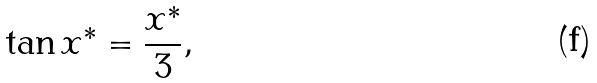Convert formula to latex. <formula><loc_0><loc_0><loc_500><loc_500>\tan x ^ { * } = \frac { x ^ { * } } { 3 } ,</formula> 